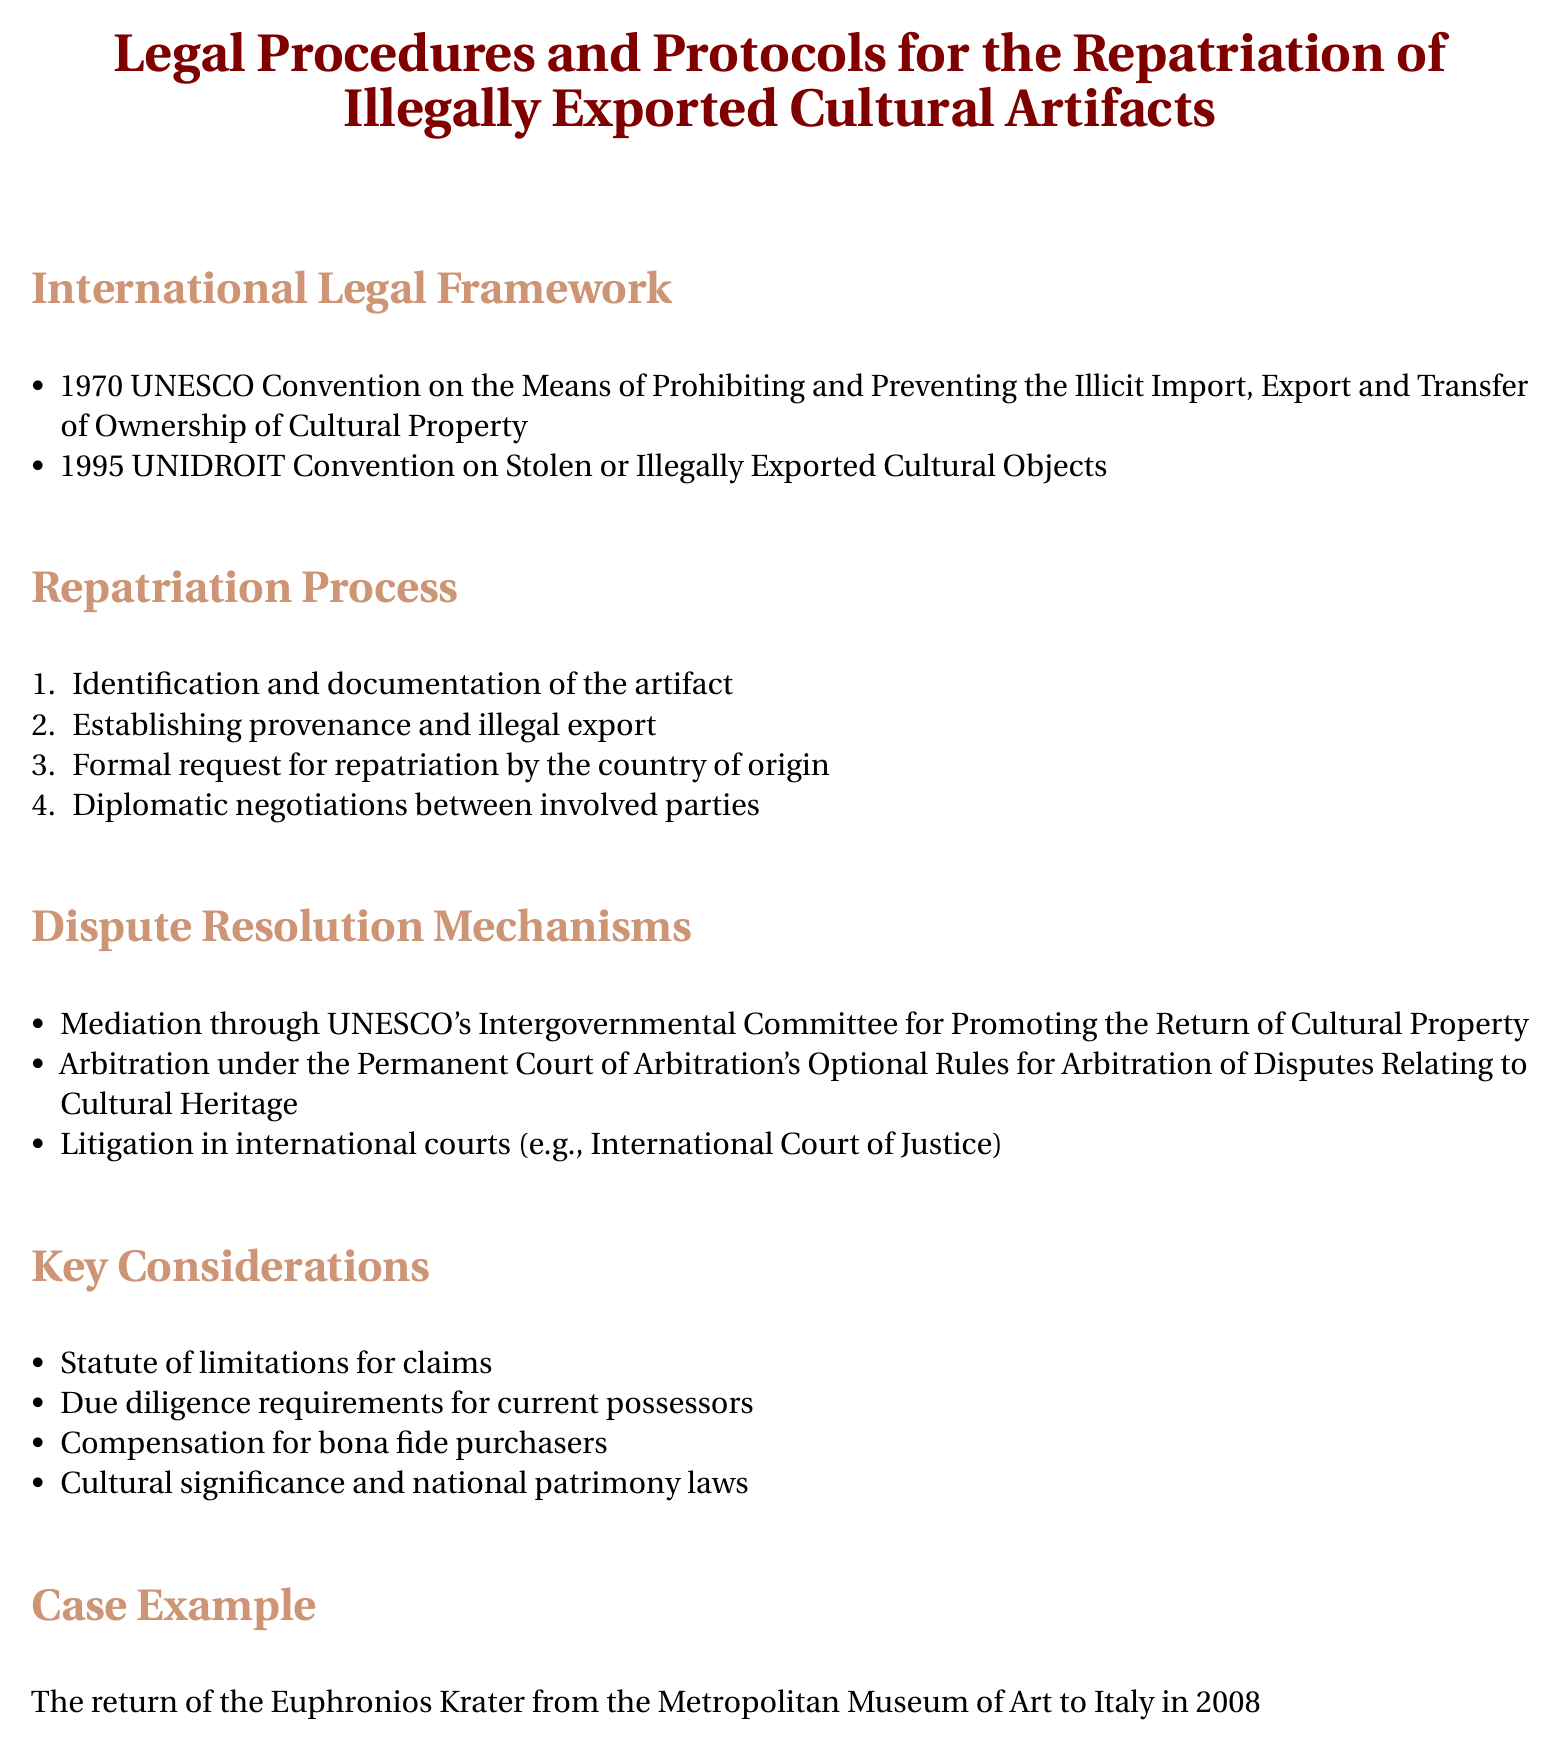What is the title of the document? The title is given at the beginning and clearly mentions the subject about repatriation procedures for cultural artifacts.
Answer: Legal Procedures and Protocols for the Repatriation of Illegally Exported Cultural Artifacts What is the first international legal framework mentioned? The document lists international frameworks sequentially, so the first one can be identified easily.
Answer: 1970 UNESCO Convention What is the fourth step in the repatriation process? The steps of the repatriation process are numbered, which allows for identifying the specific step asked for.
Answer: Diplomatic negotiations between involved parties Which dispute resolution mechanism is mentioned for mediation? The document specifies a mechanism dedicated to mediation within a particular organization.
Answer: UNESCO's Intergovernmental Committee What is one key consideration related to claims? The document lists key considerations that are essential in addressing repatriation claims.
Answer: Statute of limitations for claims Which case example is provided in the document? The document includes a specific historical case as an illustrative example of repatriation.
Answer: Euphronios Krater What is the second international legal framework listed? The document enumerates the frameworks, making it possible to locate the second item quickly.
Answer: 1995 UNIDROIT Convention What is the term used for buyers who may be compensated? The document mentions a specific group of individuals regarding compensation related to repatriation.
Answer: Bona fide purchasers 